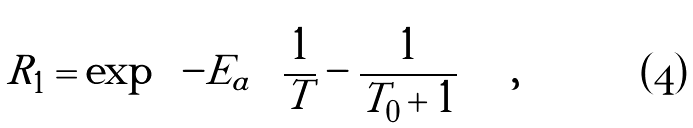Convert formula to latex. <formula><loc_0><loc_0><loc_500><loc_500>R _ { 1 } = \exp \left ( - E _ { a } \left ( \frac { 1 } { T } - \frac { 1 } { T _ { 0 } + 1 } \right ) \right ) ,</formula> 